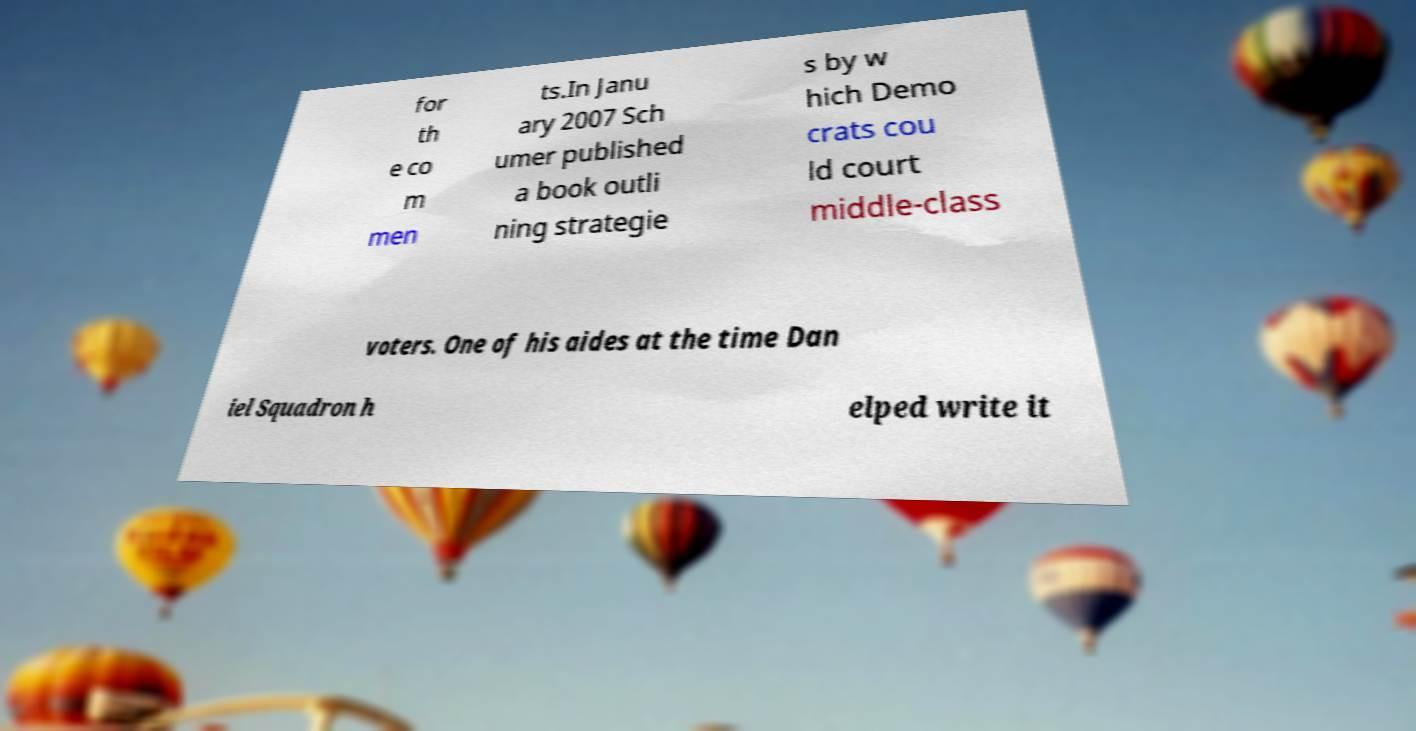Could you assist in decoding the text presented in this image and type it out clearly? for th e co m men ts.In Janu ary 2007 Sch umer published a book outli ning strategie s by w hich Demo crats cou ld court middle-class voters. One of his aides at the time Dan iel Squadron h elped write it 